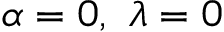<formula> <loc_0><loc_0><loc_500><loc_500>\alpha = 0 , \lambda = 0</formula> 